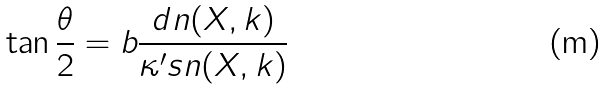<formula> <loc_0><loc_0><loc_500><loc_500>\tan \frac { \theta } { 2 } = b \frac { d n ( X , k ) } { \kappa ^ { \prime } s n ( X , k ) }</formula> 